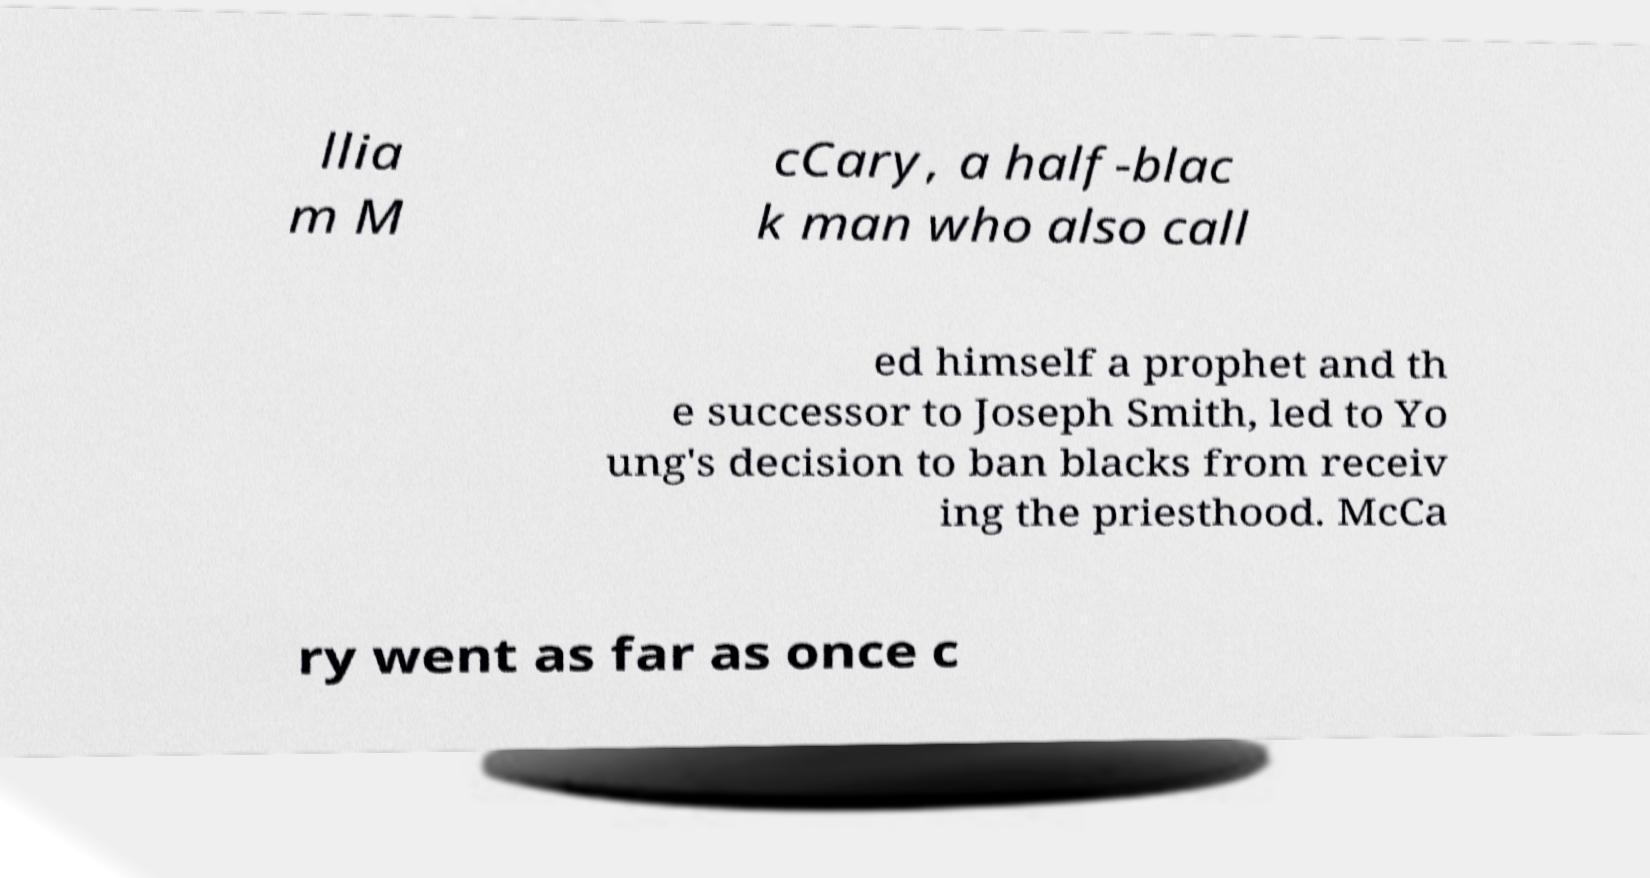What messages or text are displayed in this image? I need them in a readable, typed format. llia m M cCary, a half-blac k man who also call ed himself a prophet and th e successor to Joseph Smith, led to Yo ung's decision to ban blacks from receiv ing the priesthood. McCa ry went as far as once c 